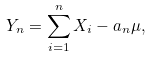Convert formula to latex. <formula><loc_0><loc_0><loc_500><loc_500>Y _ { n } = \sum _ { i = 1 } ^ { n } X _ { i } - a _ { n } \mu ,</formula> 